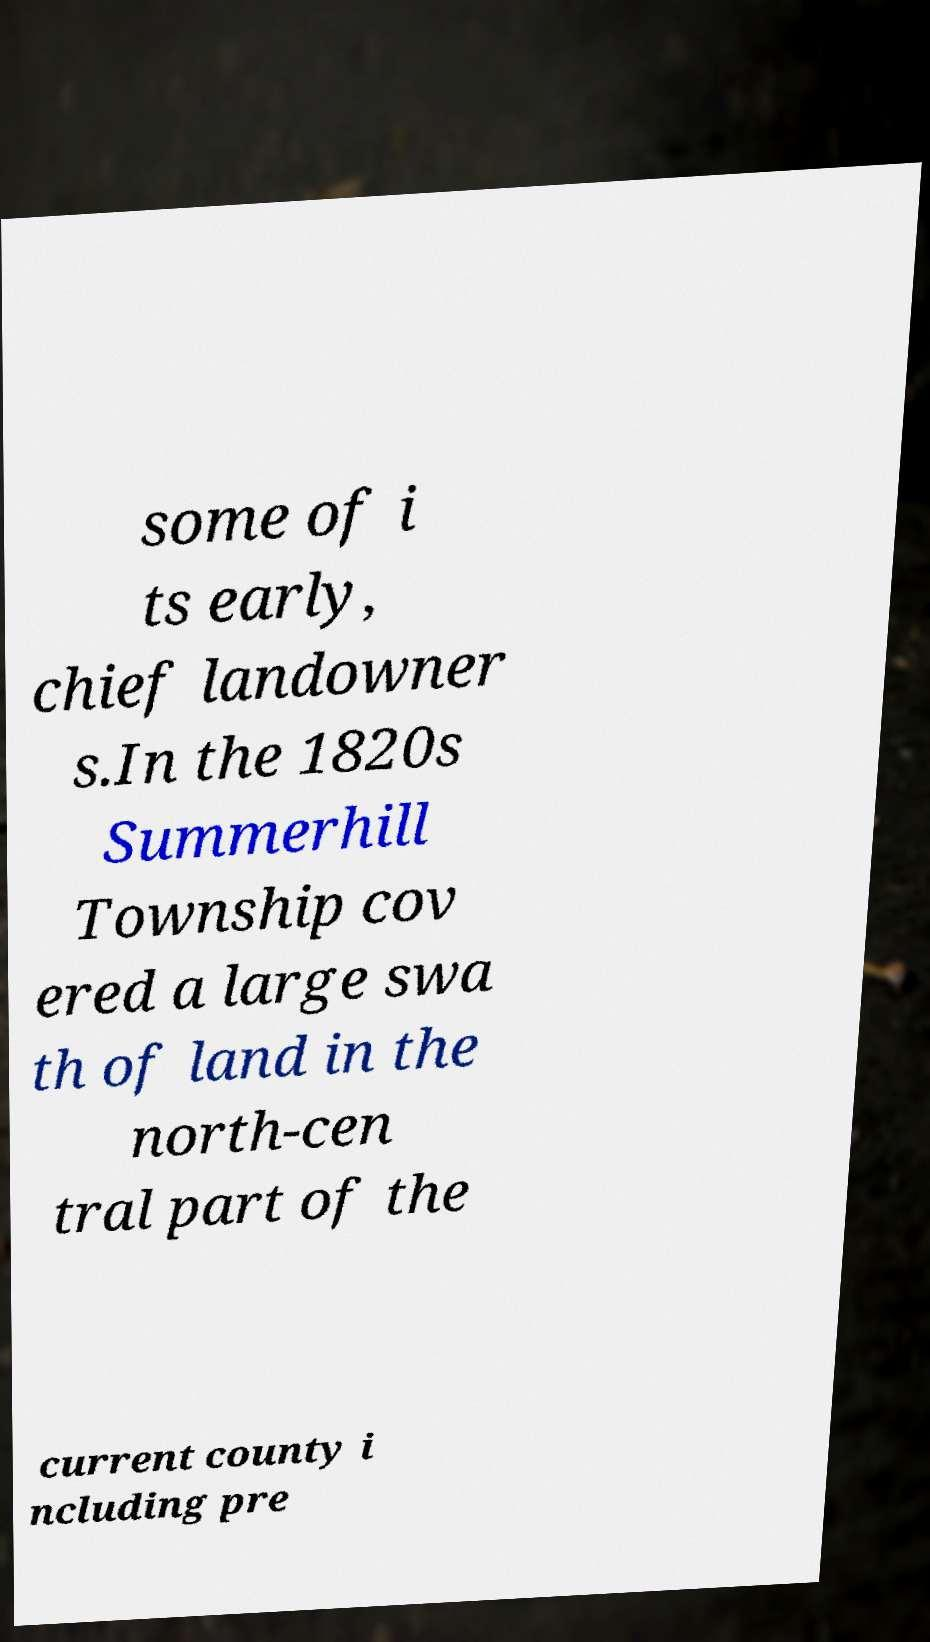I need the written content from this picture converted into text. Can you do that? some of i ts early, chief landowner s.In the 1820s Summerhill Township cov ered a large swa th of land in the north-cen tral part of the current county i ncluding pre 